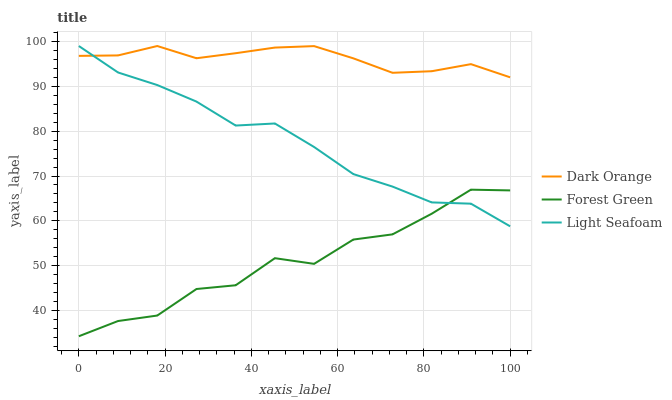Does Light Seafoam have the minimum area under the curve?
Answer yes or no. No. Does Light Seafoam have the maximum area under the curve?
Answer yes or no. No. Is Light Seafoam the smoothest?
Answer yes or no. No. Is Light Seafoam the roughest?
Answer yes or no. No. Does Light Seafoam have the lowest value?
Answer yes or no. No. Does Forest Green have the highest value?
Answer yes or no. No. Is Forest Green less than Dark Orange?
Answer yes or no. Yes. Is Dark Orange greater than Forest Green?
Answer yes or no. Yes. Does Forest Green intersect Dark Orange?
Answer yes or no. No. 